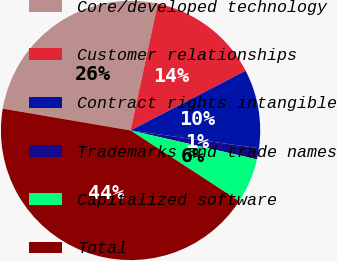<chart> <loc_0><loc_0><loc_500><loc_500><pie_chart><fcel>Core/developed technology<fcel>Customer relationships<fcel>Contract rights intangible<fcel>Trademarks and trade names<fcel>Capitalized software<fcel>Total<nl><fcel>25.67%<fcel>14.02%<fcel>9.81%<fcel>1.39%<fcel>5.6%<fcel>43.5%<nl></chart> 